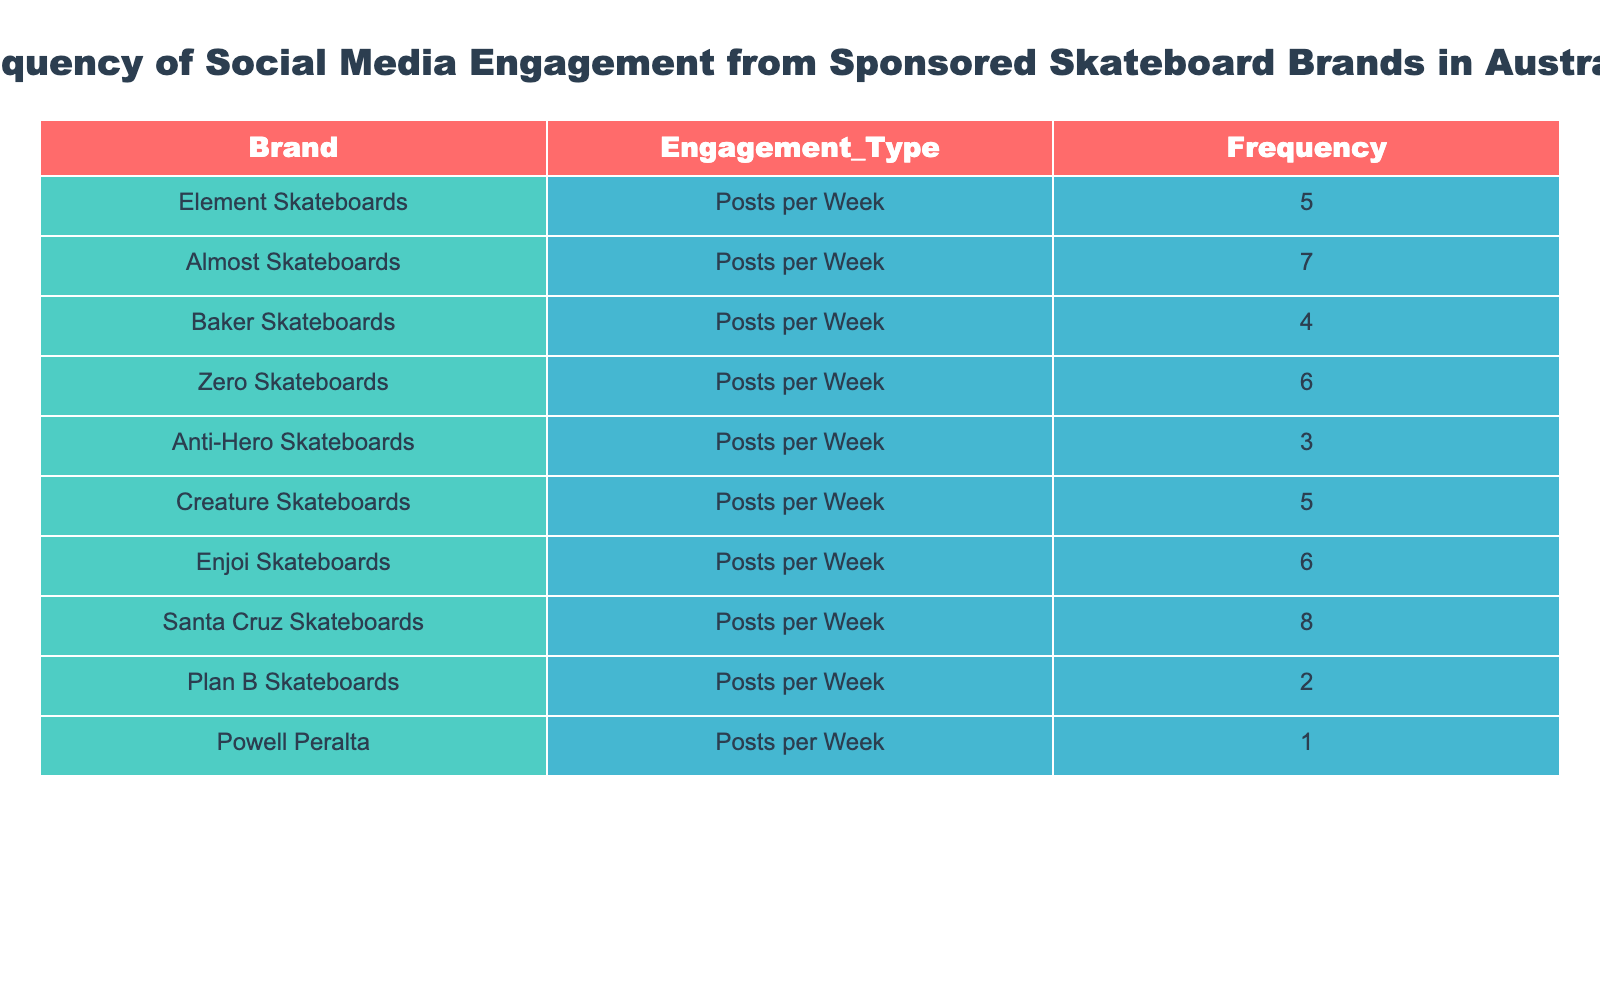What is the total number of posts per week from all the brands listed? To find the total number of posts per week, add the frequency values together: 5 + 7 + 4 + 6 + 3 + 5 + 6 + 8 + 2 + 1 = 47.
Answer: 47 Which skateboard brand has the highest frequency of posts per week? By checking the 'Frequency' column, Santa Cruz Skateboards has the highest value of 8 posts per week.
Answer: Santa Cruz Skateboards What is the average number of posts per week across all brands? First, sum the frequencies (47 as calculated before), then divide by the number of brands (10). The average is 47 / 10 = 4.7.
Answer: 4.7 Is it true that more than half of the brands post at least 5 times per week? There are 6 brands that post at least 5 times per week (Element, Almost, Zero, Creature, Enjoi, Santa Cruz), which is more than half of the total 10 brands.
Answer: Yes How many brands post 4 times per week or less? The brands that post 4 times or less are Baker (4), Anti-Hero (3), Plan B (2), and Powell Peralta (1), totaling four brands.
Answer: 4 Which brands have a frequency of posts equal to or greater than 6? The brands with 6 or more posts are Almost (7), Zero (6), Enjoi (6), and Santa Cruz (8), totaling four brands.
Answer: 4 What is the frequency of posts for the brand with the least engagement? Powell Peralta has the least engagement with 1 post per week.
Answer: 1 What is the difference between the highest and lowest frequency of posts? The highest frequency is 8 (Santa Cruz) and the lowest frequency is 1 (Powell Peralta). The difference is 8 - 1 = 7.
Answer: 7 How many brands post more frequently than Zero Skateboards? The brands that post more frequently than Zero (6) are Almost (7) and Santa Cruz (8), resulting in two brands.
Answer: 2 